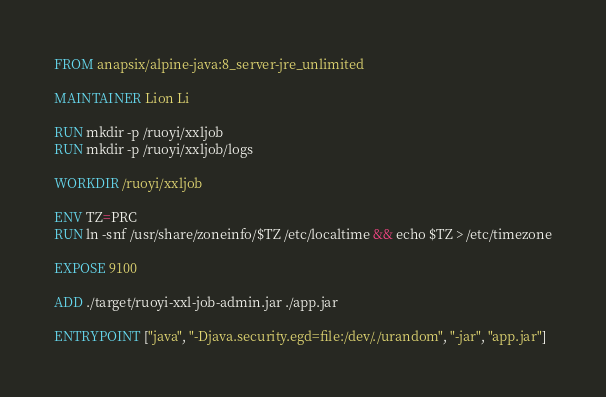Convert code to text. <code><loc_0><loc_0><loc_500><loc_500><_Dockerfile_>FROM anapsix/alpine-java:8_server-jre_unlimited

MAINTAINER Lion Li

RUN mkdir -p /ruoyi/xxljob
RUN mkdir -p /ruoyi/xxljob/logs

WORKDIR /ruoyi/xxljob

ENV TZ=PRC
RUN ln -snf /usr/share/zoneinfo/$TZ /etc/localtime && echo $TZ > /etc/timezone

EXPOSE 9100

ADD ./target/ruoyi-xxl-job-admin.jar ./app.jar

ENTRYPOINT ["java", "-Djava.security.egd=file:/dev/./urandom", "-jar", "app.jar"]</code> 